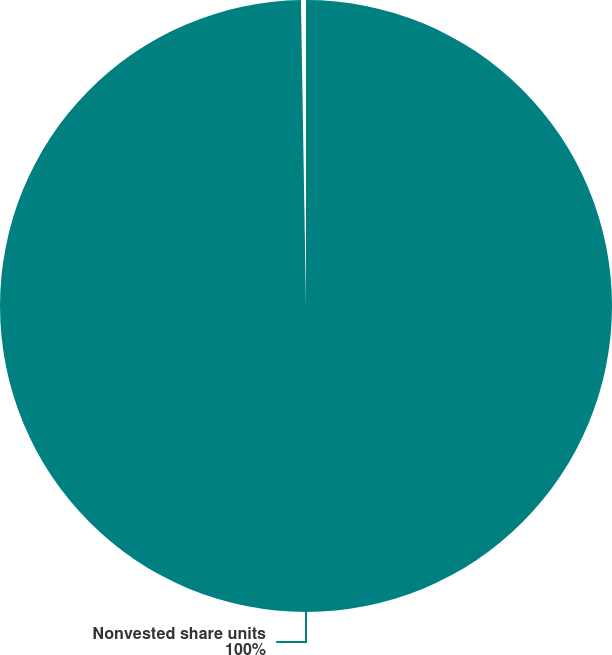Convert chart. <chart><loc_0><loc_0><loc_500><loc_500><pie_chart><fcel>Nonvested share units<nl><fcel>100.0%<nl></chart> 